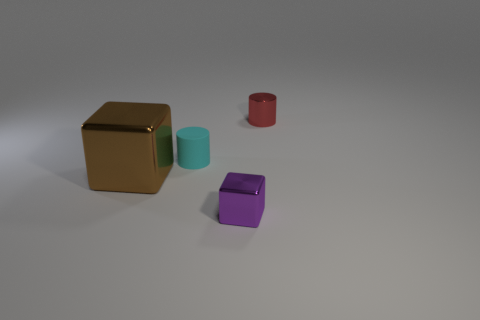Subtract all red cylinders. How many cylinders are left? 1 Subtract 2 cylinders. How many cylinders are left? 0 Add 4 tiny brown cylinders. How many objects exist? 8 Subtract 0 blue cubes. How many objects are left? 4 Subtract all blue cylinders. Subtract all brown cubes. How many cylinders are left? 2 Subtract all red cylinders. How many brown blocks are left? 1 Subtract all small matte objects. Subtract all large blocks. How many objects are left? 2 Add 1 small purple objects. How many small purple objects are left? 2 Add 1 red balls. How many red balls exist? 1 